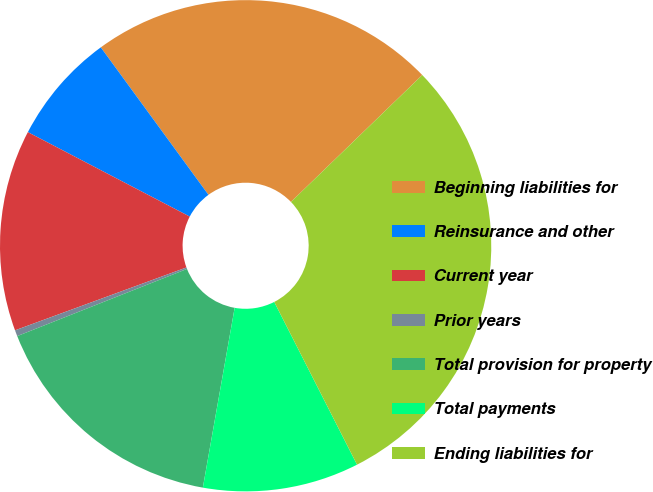Convert chart to OTSL. <chart><loc_0><loc_0><loc_500><loc_500><pie_chart><fcel>Beginning liabilities for<fcel>Reinsurance and other<fcel>Current year<fcel>Prior years<fcel>Total provision for property<fcel>Total payments<fcel>Ending liabilities for<nl><fcel>22.81%<fcel>7.31%<fcel>13.25%<fcel>0.4%<fcel>16.22%<fcel>10.28%<fcel>29.74%<nl></chart> 